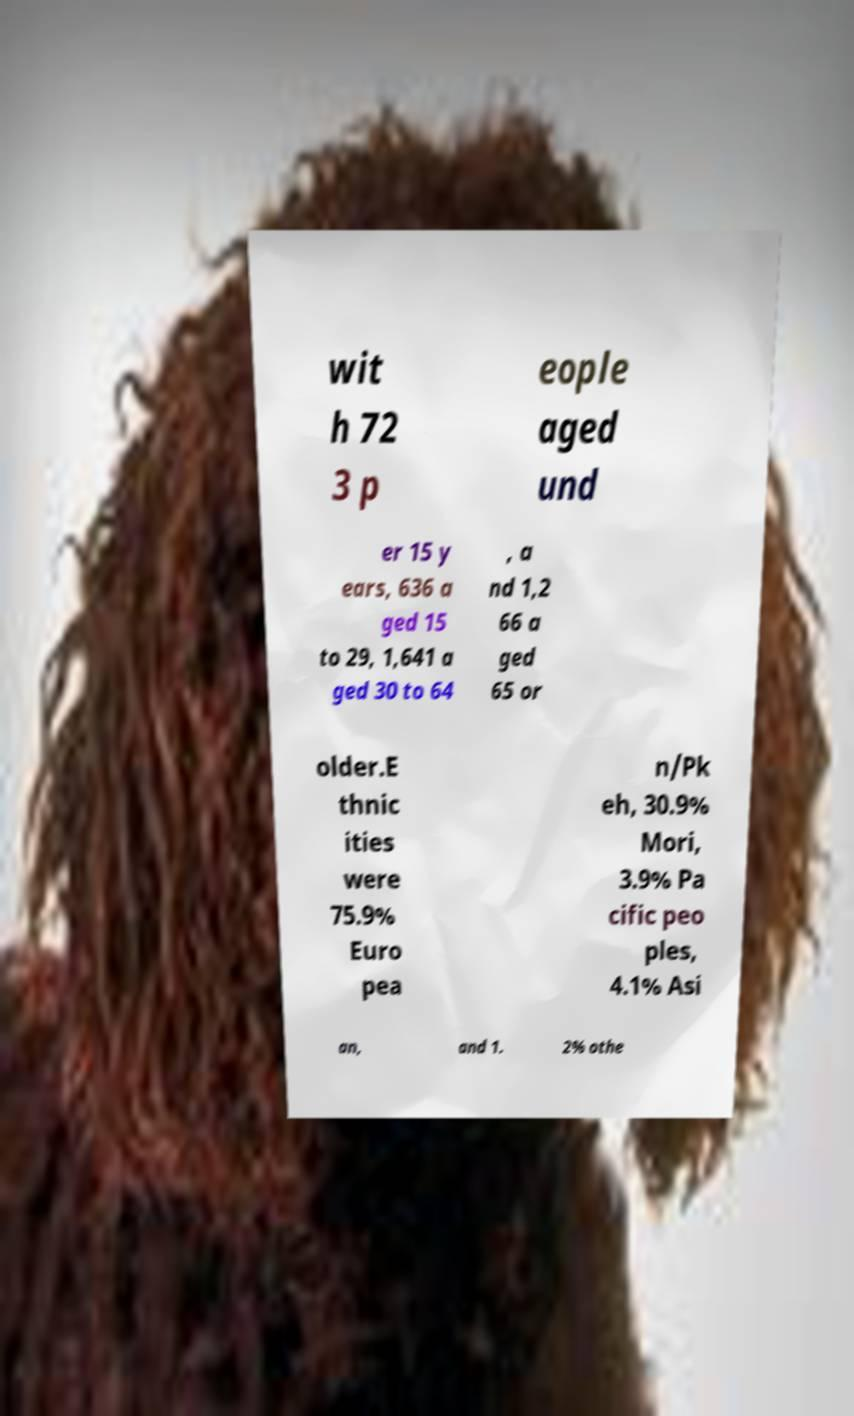There's text embedded in this image that I need extracted. Can you transcribe it verbatim? wit h 72 3 p eople aged und er 15 y ears, 636 a ged 15 to 29, 1,641 a ged 30 to 64 , a nd 1,2 66 a ged 65 or older.E thnic ities were 75.9% Euro pea n/Pk eh, 30.9% Mori, 3.9% Pa cific peo ples, 4.1% Asi an, and 1. 2% othe 